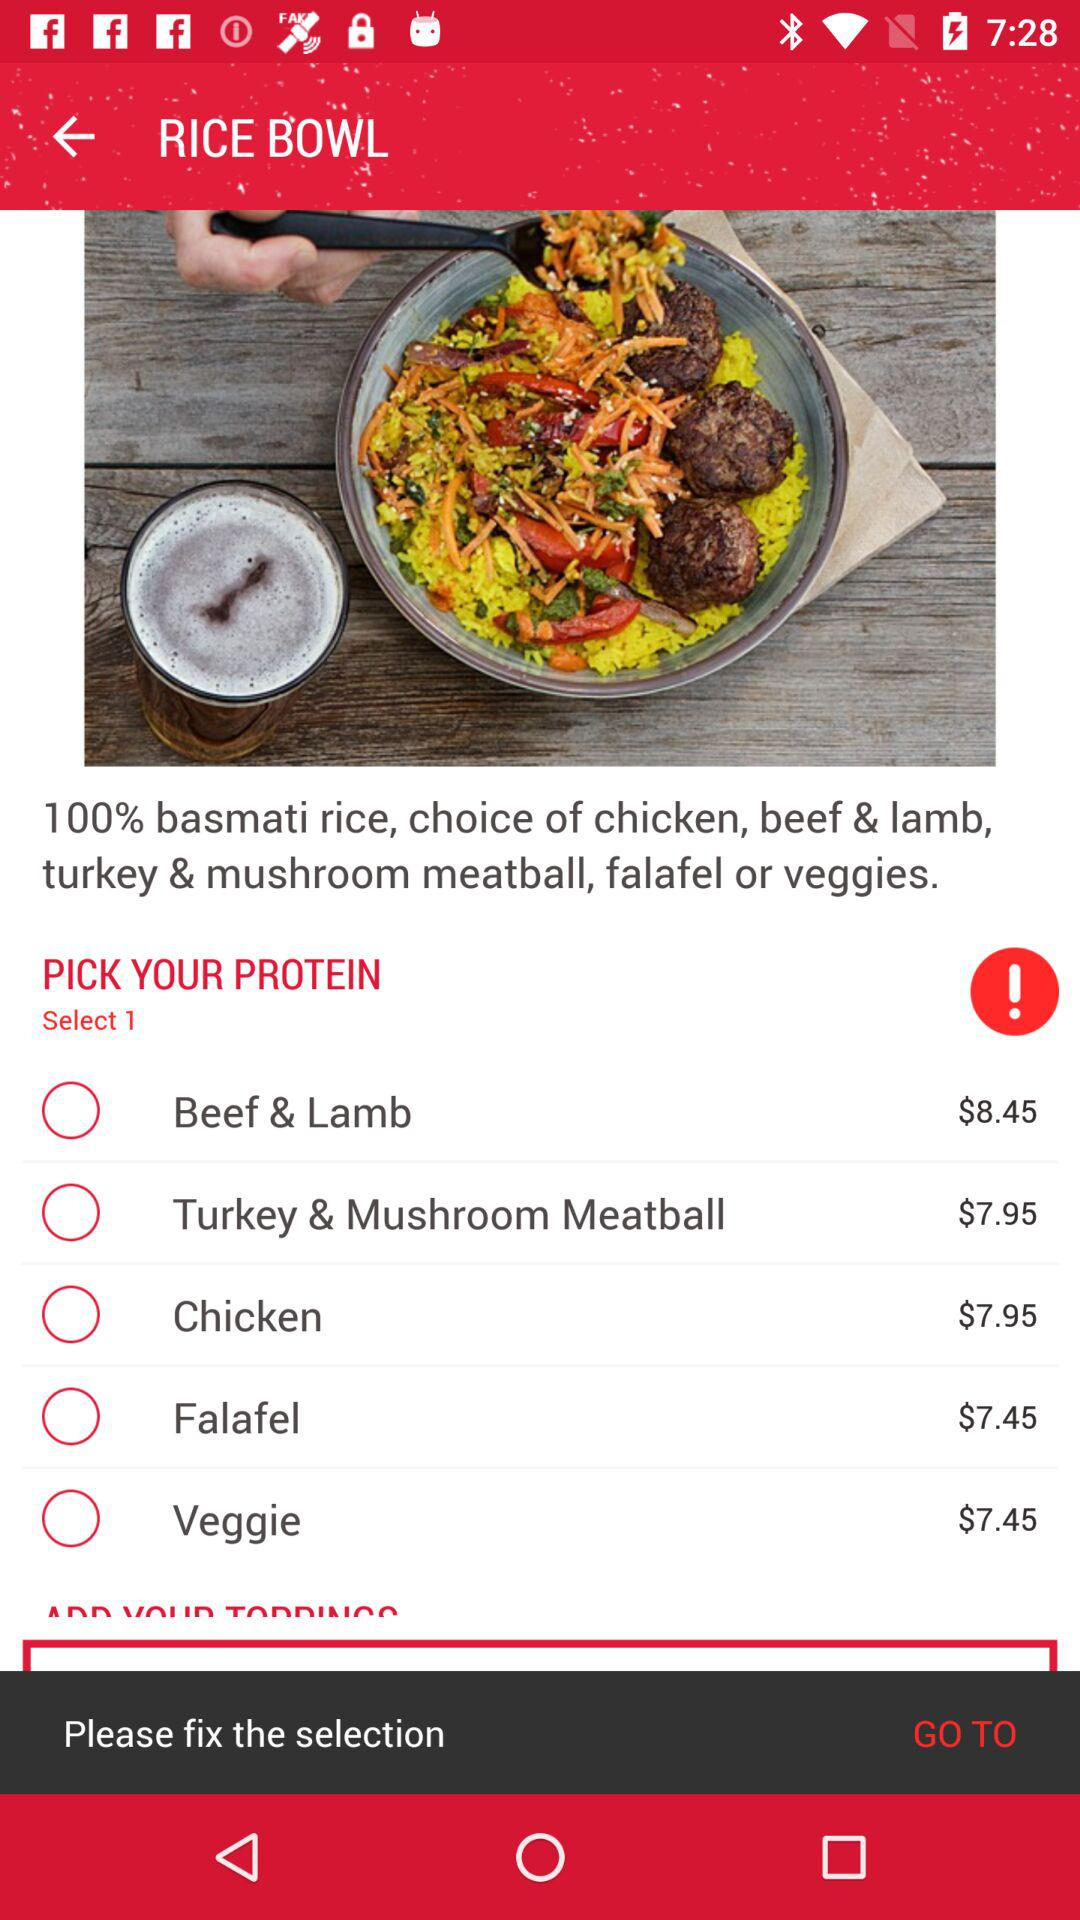What's the cost of "Turkey & Mushroom Meatball"? The cost of "Turkey & Mushroom Meatball" is $7.95. 